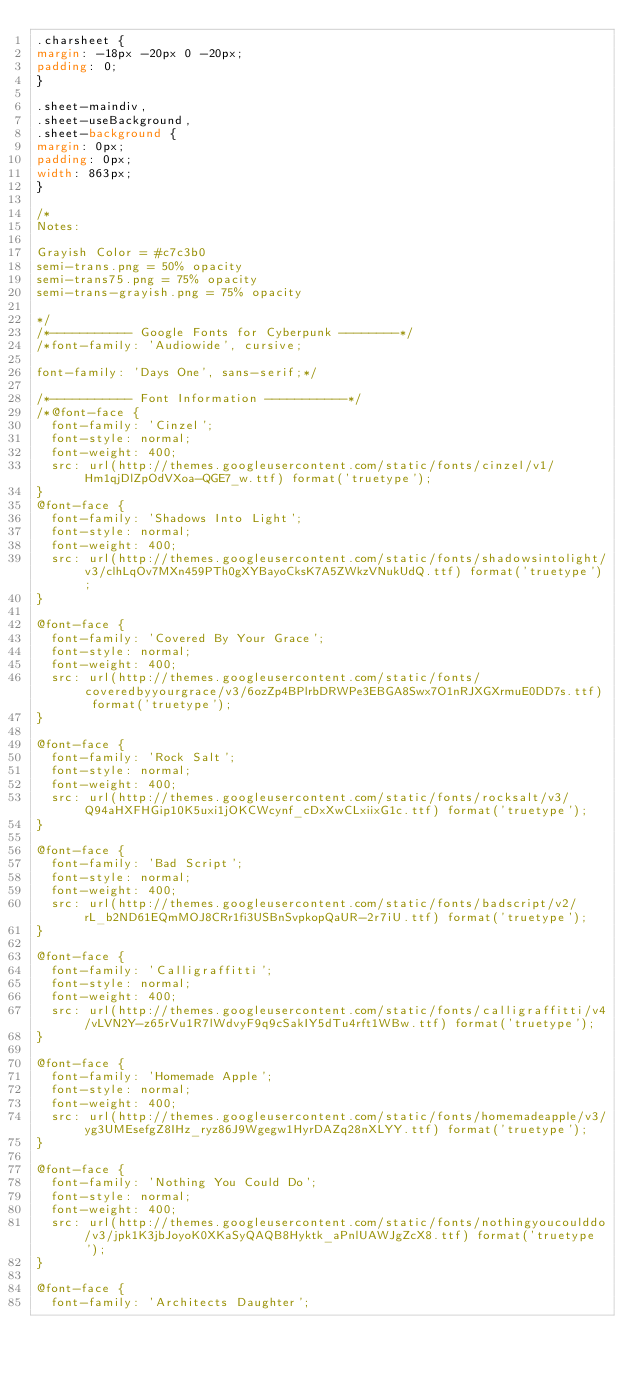Convert code to text. <code><loc_0><loc_0><loc_500><loc_500><_CSS_>.charsheet {
margin: -18px -20px 0 -20px;
padding: 0;
}

.sheet-maindiv,
.sheet-useBackground,
.sheet-background {
margin: 0px;
padding: 0px;
width: 863px;
}

/*
Notes:  

Grayish Color = #c7c3b0
semi-trans.png = 50% opacity
semi-trans75.png = 75% opacity
semi-trans-grayish.png = 75% opacity

*/
/*----------- Google Fonts for Cyberpunk --------*/
/*font-family: 'Audiowide', cursive;

font-family: 'Days One', sans-serif;*/

/*----------- Font Information -----------*/
/*@font-face {
  font-family: 'Cinzel';
  font-style: normal;
  font-weight: 400;
  src: url(http://themes.googleusercontent.com/static/fonts/cinzel/v1/Hm1qjDlZpOdVXoa-QGE7_w.ttf) format('truetype');
}
@font-face {
  font-family: 'Shadows Into Light';
  font-style: normal;
  font-weight: 400;
  src: url(http://themes.googleusercontent.com/static/fonts/shadowsintolight/v3/clhLqOv7MXn459PTh0gXYBayoCksK7A5ZWkzVNukUdQ.ttf) format('truetype');
}

@font-face {
  font-family: 'Covered By Your Grace';
  font-style: normal;
  font-weight: 400;
  src: url(http://themes.googleusercontent.com/static/fonts/coveredbyyourgrace/v3/6ozZp4BPlrbDRWPe3EBGA8Swx7O1nRJXGXrmuE0DD7s.ttf) format('truetype');
}

@font-face {
  font-family: 'Rock Salt';
  font-style: normal;
  font-weight: 400;
  src: url(http://themes.googleusercontent.com/static/fonts/rocksalt/v3/Q94aHXFHGip10K5uxi1jOKCWcynf_cDxXwCLxiixG1c.ttf) format('truetype');
}

@font-face {
  font-family: 'Bad Script';
  font-style: normal;
  font-weight: 400;
  src: url(http://themes.googleusercontent.com/static/fonts/badscript/v2/rL_b2ND61EQmMOJ8CRr1fi3USBnSvpkopQaUR-2r7iU.ttf) format('truetype');
}

@font-face {
  font-family: 'Calligraffitti';
  font-style: normal;
  font-weight: 400;
  src: url(http://themes.googleusercontent.com/static/fonts/calligraffitti/v4/vLVN2Y-z65rVu1R7lWdvyF9q9cSakIY5dTu4rft1WBw.ttf) format('truetype');
}

@font-face {
  font-family: 'Homemade Apple';
  font-style: normal;
  font-weight: 400;
  src: url(http://themes.googleusercontent.com/static/fonts/homemadeapple/v3/yg3UMEsefgZ8IHz_ryz86J9Wgegw1HyrDAZq28nXLYY.ttf) format('truetype');
}

@font-face {
  font-family: 'Nothing You Could Do';
  font-style: normal;
  font-weight: 400;
  src: url(http://themes.googleusercontent.com/static/fonts/nothingyoucoulddo/v3/jpk1K3jbJoyoK0XKaSyQAQB8Hyktk_aPnlUAWJgZcX8.ttf) format('truetype');
}

@font-face {
  font-family: 'Architects Daughter';</code> 